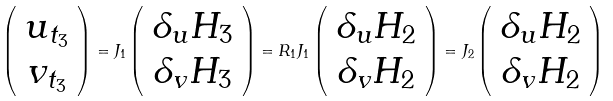Convert formula to latex. <formula><loc_0><loc_0><loc_500><loc_500>\left ( \begin{array} { c } u _ { t _ { 3 } } \\ v _ { t _ { 3 } } \end{array} \right ) = J _ { 1 } \left ( \begin{array} { c } \delta _ { u } H _ { 3 } \\ \delta _ { v } H _ { 3 } \end{array} \right ) = R _ { 1 } J _ { 1 } \left ( \begin{array} { c } \delta _ { u } H _ { 2 } \\ \delta _ { v } H _ { 2 } \end{array} \right ) = J _ { 2 } \left ( \begin{array} { c } \delta _ { u } H _ { 2 } \\ \delta _ { v } H _ { 2 } \end{array} \right )</formula> 